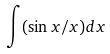Convert formula to latex. <formula><loc_0><loc_0><loc_500><loc_500>\int ( \sin x / x ) d x</formula> 